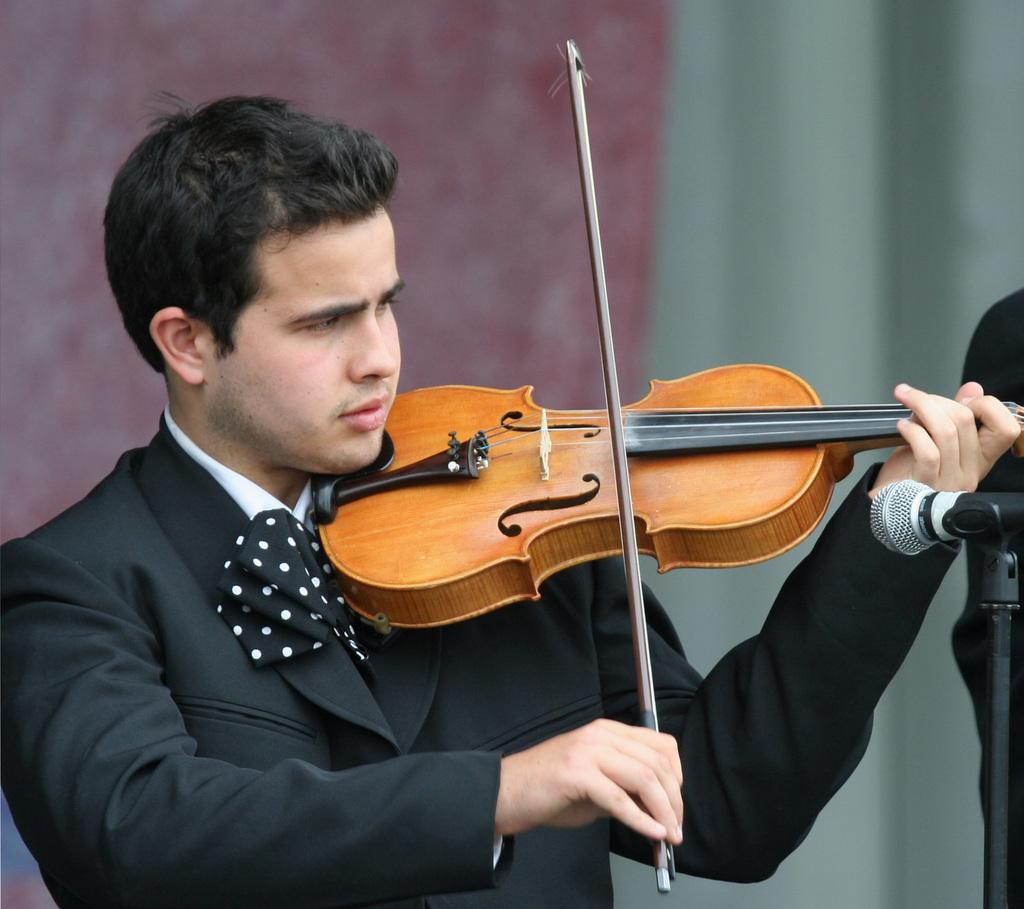What is the man in the image doing? The man is standing and playing a violin. What object is present in the image that is typically used for amplifying sound? There is a microphone on a stand in the image. What can be seen in the background of the image? There is a wall and a curtain in the background of the image. How many feelings can be seen on the man's face in the image? Feelings cannot be seen on the man's face in the image, as it is a photograph and does not convey emotions. What is the amount of water visible in the image? There is no water present in the image. 